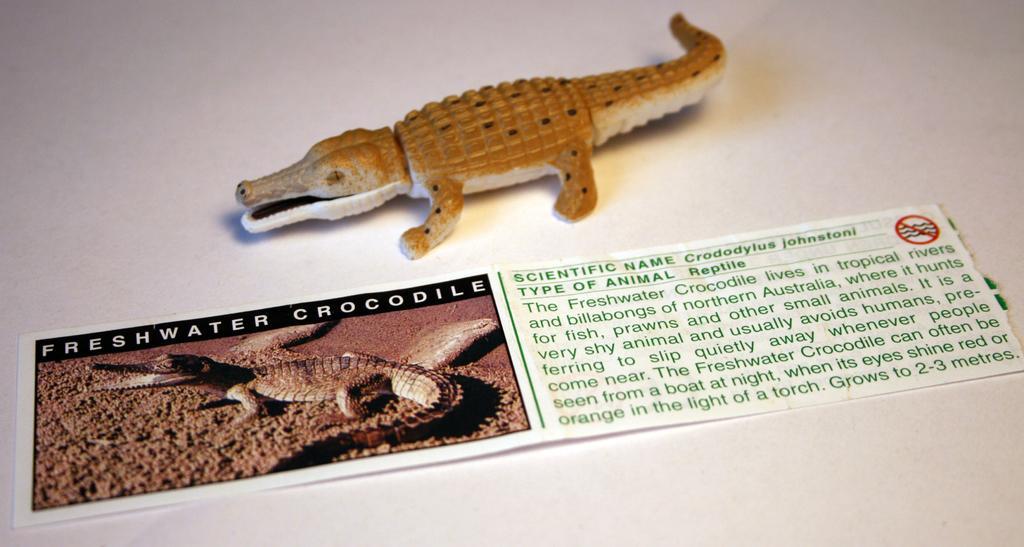Please provide a concise description of this image. In this image we can see toy lizard and a paper. On paper lizard image and some text is written. 